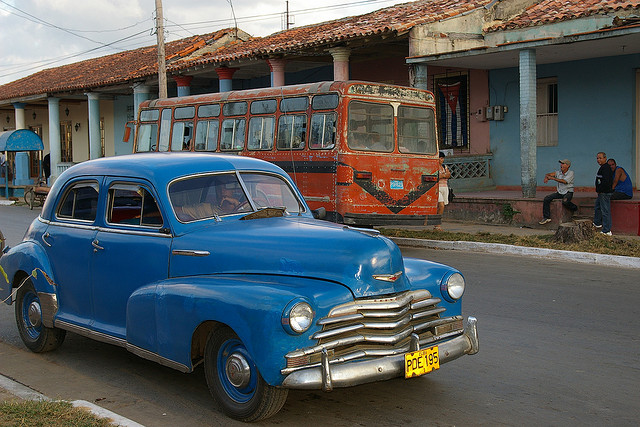Identify the text displayed in this image. PDE 195 